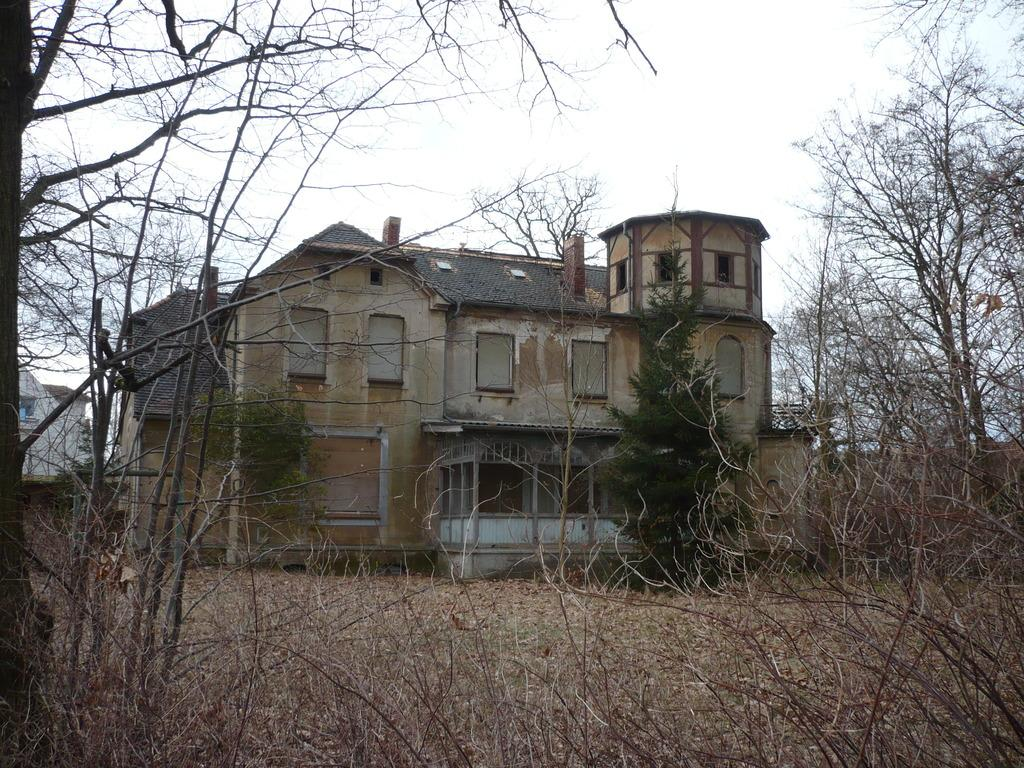What type of vegetation is visible in the front of the image? There is dry grass and plants in the front of the image. What can be seen in the background of the image? There is a building and many trees in the background of the image. What page is the sail located on in the image? There is no sail present in the image, so it cannot be located on a page. 